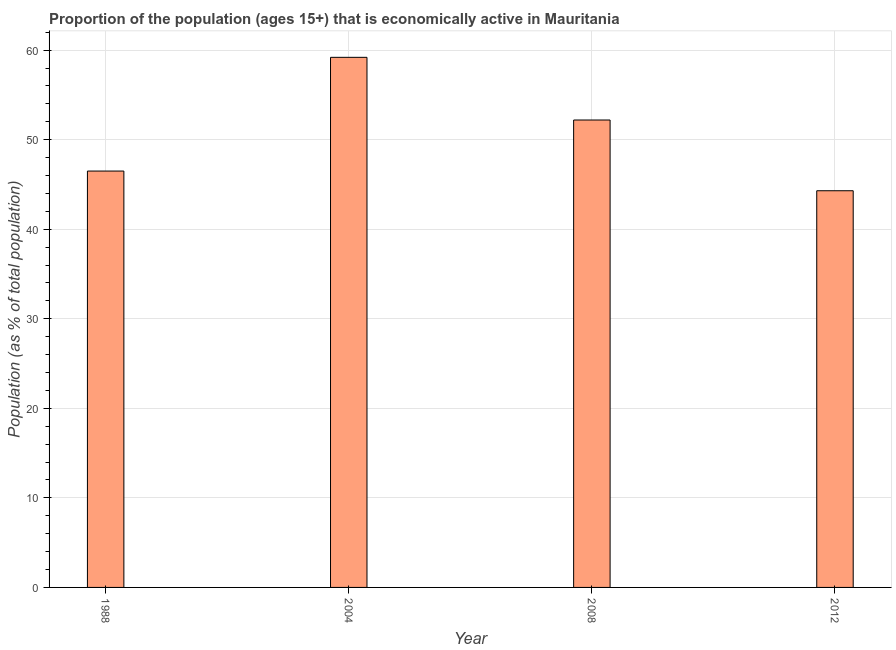Does the graph contain grids?
Your response must be concise. Yes. What is the title of the graph?
Keep it short and to the point. Proportion of the population (ages 15+) that is economically active in Mauritania. What is the label or title of the Y-axis?
Make the answer very short. Population (as % of total population). What is the percentage of economically active population in 2004?
Make the answer very short. 59.2. Across all years, what is the maximum percentage of economically active population?
Keep it short and to the point. 59.2. Across all years, what is the minimum percentage of economically active population?
Provide a succinct answer. 44.3. In which year was the percentage of economically active population maximum?
Ensure brevity in your answer.  2004. What is the sum of the percentage of economically active population?
Give a very brief answer. 202.2. What is the difference between the percentage of economically active population in 2004 and 2012?
Provide a short and direct response. 14.9. What is the average percentage of economically active population per year?
Provide a short and direct response. 50.55. What is the median percentage of economically active population?
Your answer should be compact. 49.35. Is the percentage of economically active population in 1988 less than that in 2008?
Keep it short and to the point. Yes. Is the difference between the percentage of economically active population in 2008 and 2012 greater than the difference between any two years?
Offer a very short reply. No. What is the difference between the highest and the second highest percentage of economically active population?
Your response must be concise. 7. What is the difference between the highest and the lowest percentage of economically active population?
Give a very brief answer. 14.9. In how many years, is the percentage of economically active population greater than the average percentage of economically active population taken over all years?
Provide a succinct answer. 2. Are all the bars in the graph horizontal?
Your response must be concise. No. How many years are there in the graph?
Offer a terse response. 4. What is the Population (as % of total population) in 1988?
Give a very brief answer. 46.5. What is the Population (as % of total population) of 2004?
Keep it short and to the point. 59.2. What is the Population (as % of total population) in 2008?
Make the answer very short. 52.2. What is the Population (as % of total population) of 2012?
Offer a terse response. 44.3. What is the difference between the Population (as % of total population) in 1988 and 2004?
Keep it short and to the point. -12.7. What is the difference between the Population (as % of total population) in 1988 and 2012?
Make the answer very short. 2.2. What is the difference between the Population (as % of total population) in 2004 and 2012?
Provide a short and direct response. 14.9. What is the difference between the Population (as % of total population) in 2008 and 2012?
Your answer should be very brief. 7.9. What is the ratio of the Population (as % of total population) in 1988 to that in 2004?
Offer a terse response. 0.79. What is the ratio of the Population (as % of total population) in 1988 to that in 2008?
Provide a short and direct response. 0.89. What is the ratio of the Population (as % of total population) in 2004 to that in 2008?
Provide a succinct answer. 1.13. What is the ratio of the Population (as % of total population) in 2004 to that in 2012?
Offer a very short reply. 1.34. What is the ratio of the Population (as % of total population) in 2008 to that in 2012?
Ensure brevity in your answer.  1.18. 